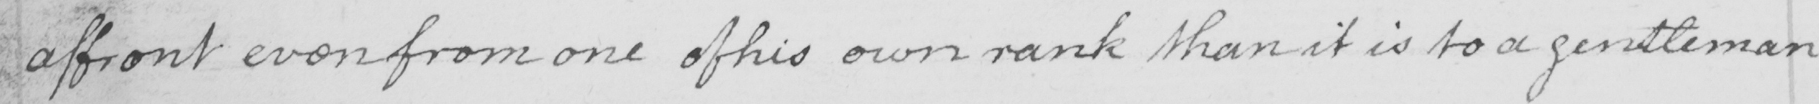Please transcribe the handwritten text in this image. affront even from one of his own rank than it is to a gentleman 